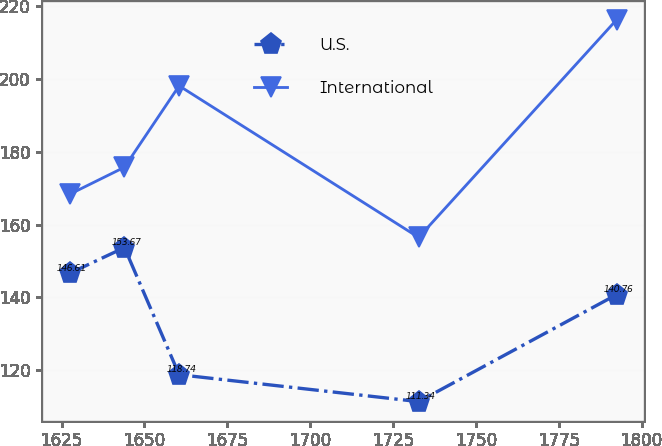Convert chart. <chart><loc_0><loc_0><loc_500><loc_500><line_chart><ecel><fcel>U.S.<fcel>International<nl><fcel>1627.47<fcel>146.61<fcel>168.33<nl><fcel>1643.97<fcel>153.67<fcel>175.75<nl><fcel>1660.47<fcel>118.74<fcel>198.12<nl><fcel>1732.73<fcel>111.34<fcel>156.46<nl><fcel>1792.49<fcel>140.76<fcel>216.31<nl></chart> 